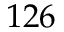<formula> <loc_0><loc_0><loc_500><loc_500>1 2 6</formula> 